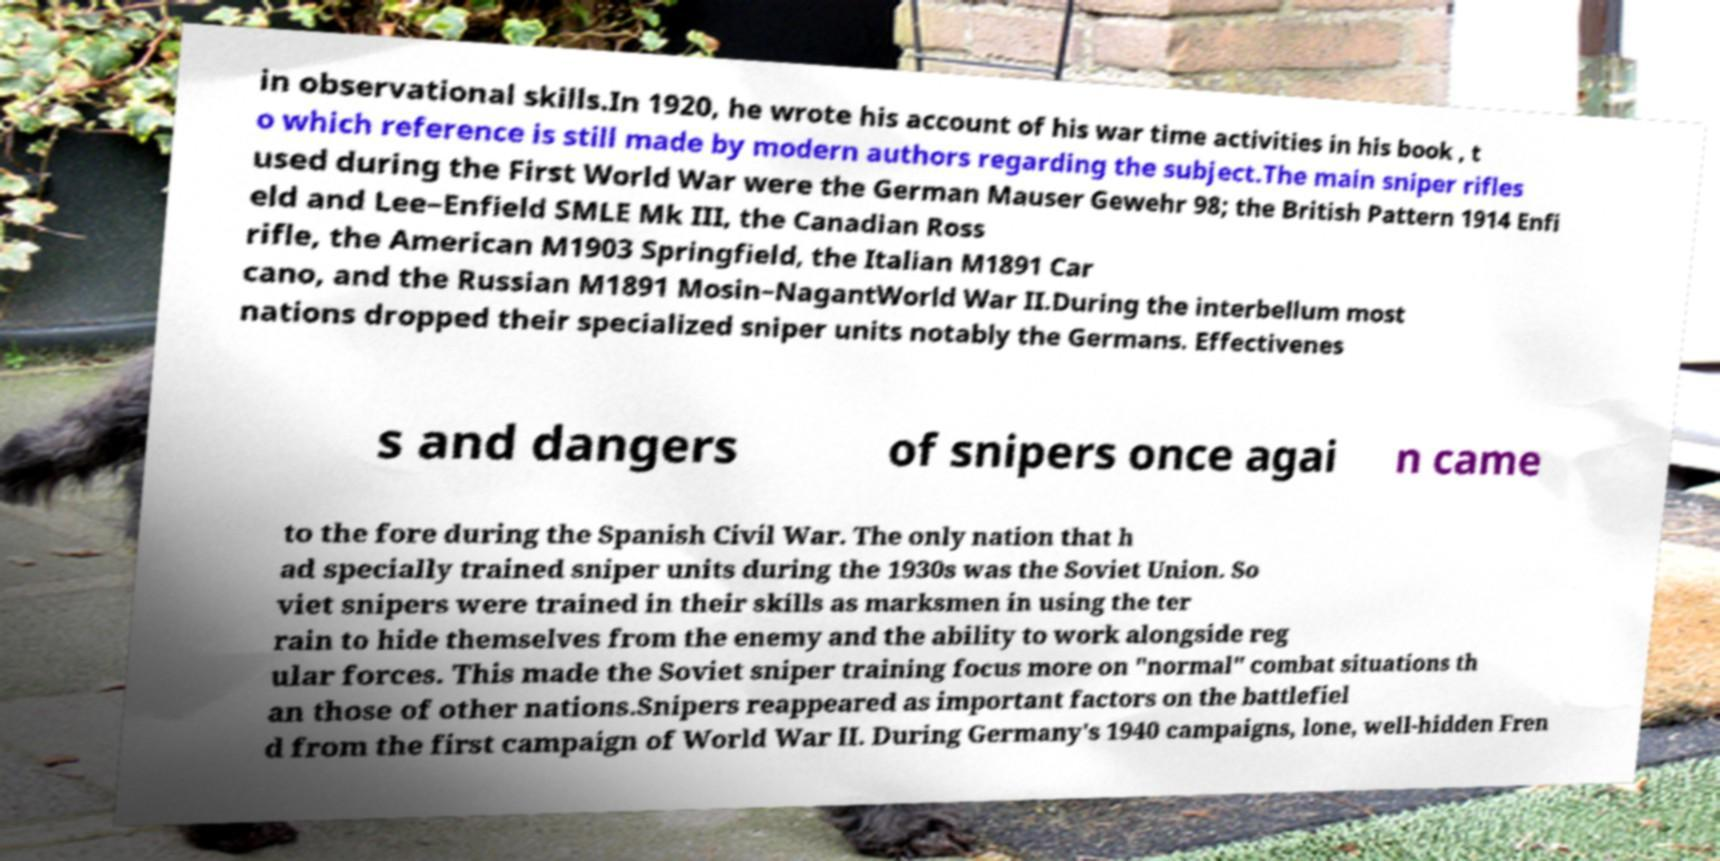What messages or text are displayed in this image? I need them in a readable, typed format. in observational skills.In 1920, he wrote his account of his war time activities in his book , t o which reference is still made by modern authors regarding the subject.The main sniper rifles used during the First World War were the German Mauser Gewehr 98; the British Pattern 1914 Enfi eld and Lee–Enfield SMLE Mk III, the Canadian Ross rifle, the American M1903 Springfield, the Italian M1891 Car cano, and the Russian M1891 Mosin–NagantWorld War II.During the interbellum most nations dropped their specialized sniper units notably the Germans. Effectivenes s and dangers of snipers once agai n came to the fore during the Spanish Civil War. The only nation that h ad specially trained sniper units during the 1930s was the Soviet Union. So viet snipers were trained in their skills as marksmen in using the ter rain to hide themselves from the enemy and the ability to work alongside reg ular forces. This made the Soviet sniper training focus more on "normal" combat situations th an those of other nations.Snipers reappeared as important factors on the battlefiel d from the first campaign of World War II. During Germany's 1940 campaigns, lone, well-hidden Fren 